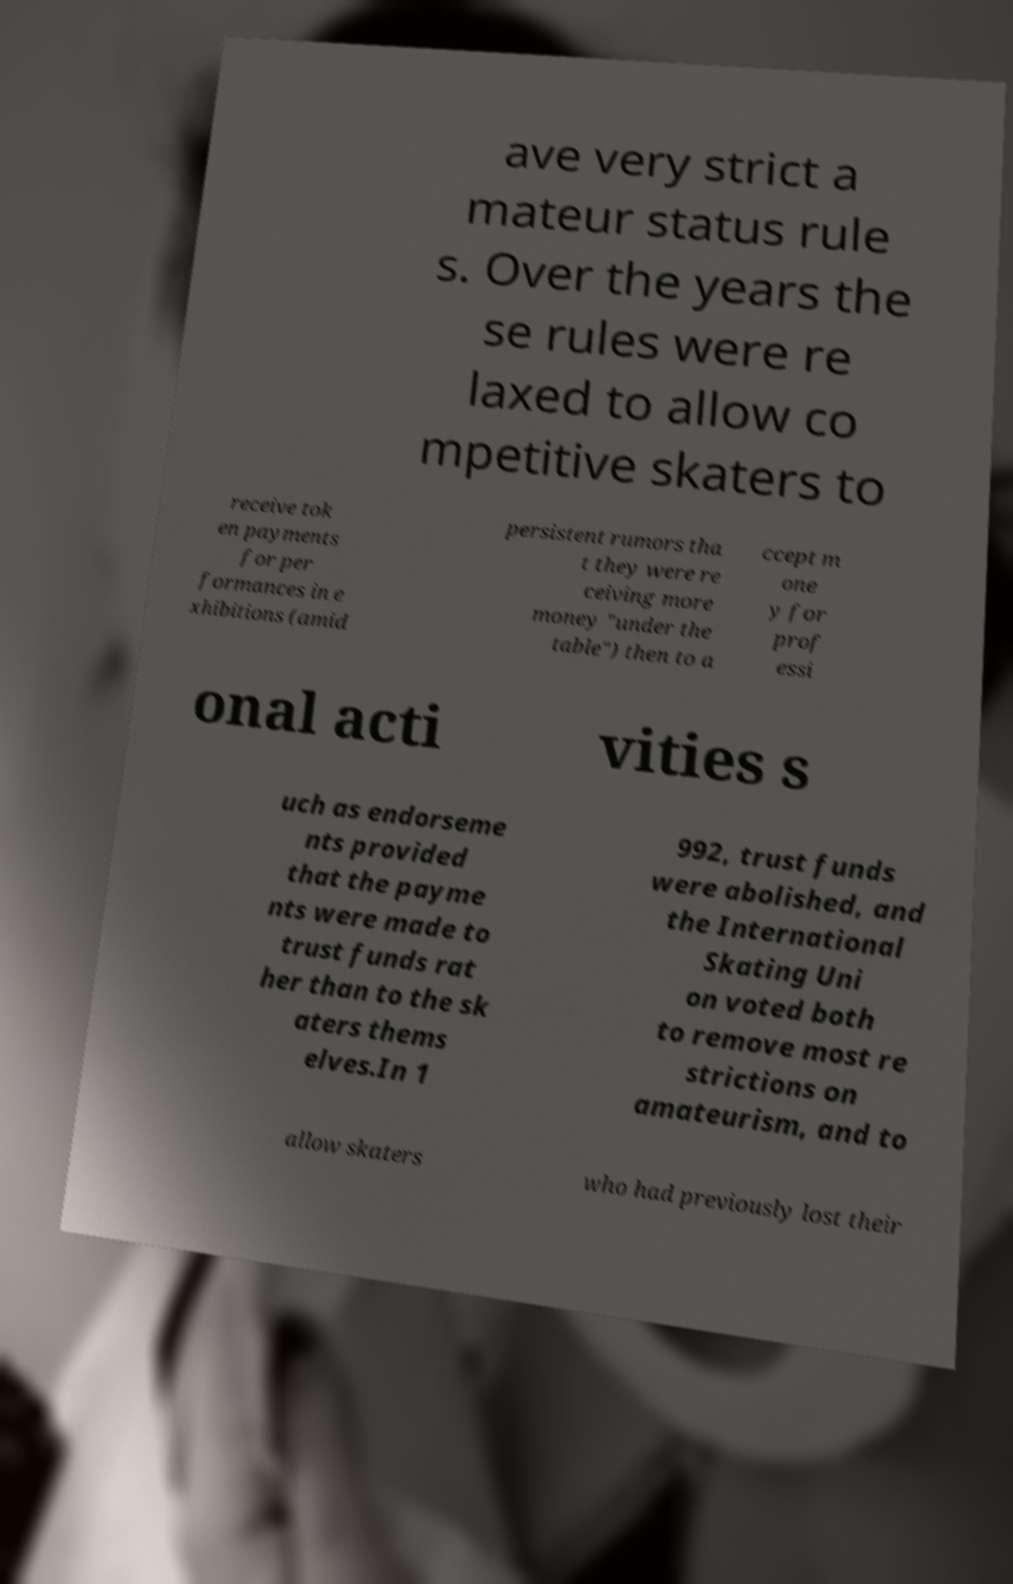Please identify and transcribe the text found in this image. ave very strict a mateur status rule s. Over the years the se rules were re laxed to allow co mpetitive skaters to receive tok en payments for per formances in e xhibitions (amid persistent rumors tha t they were re ceiving more money "under the table") then to a ccept m one y for prof essi onal acti vities s uch as endorseme nts provided that the payme nts were made to trust funds rat her than to the sk aters thems elves.In 1 992, trust funds were abolished, and the International Skating Uni on voted both to remove most re strictions on amateurism, and to allow skaters who had previously lost their 